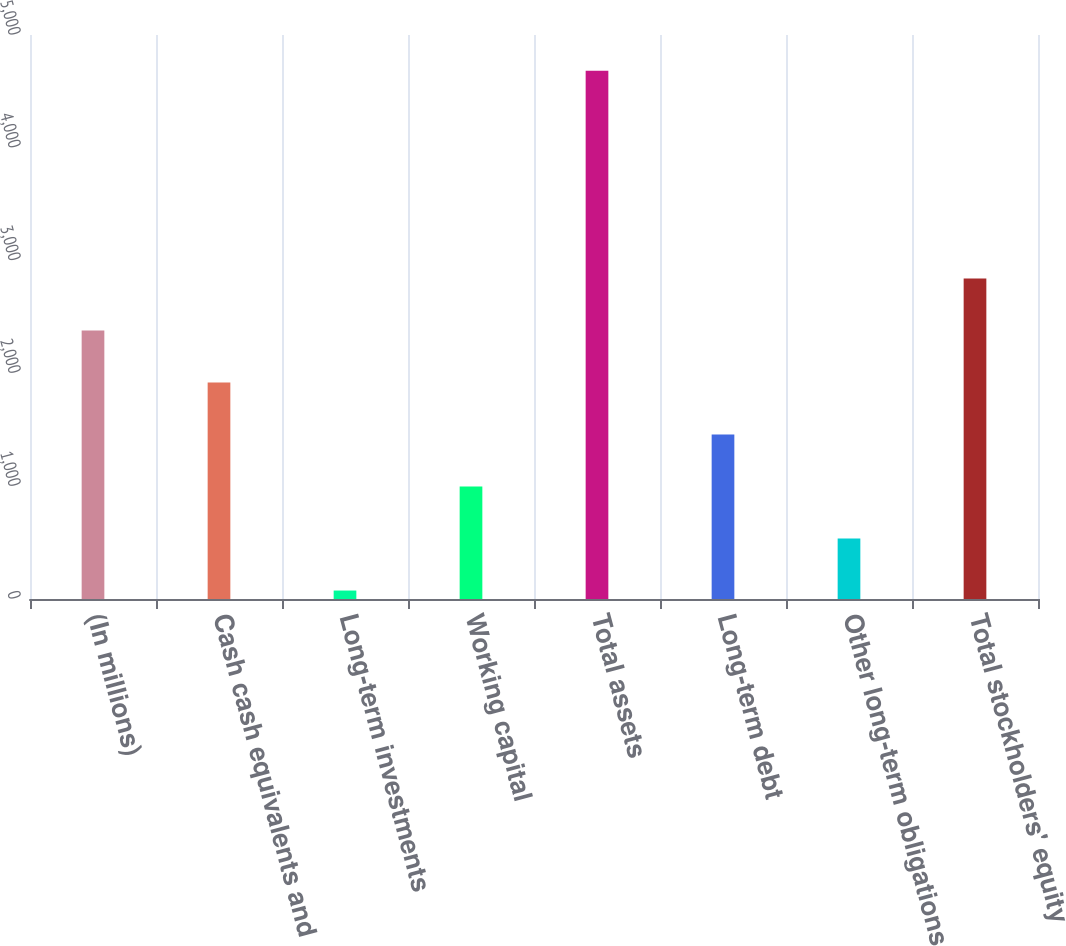<chart> <loc_0><loc_0><loc_500><loc_500><bar_chart><fcel>(In millions)<fcel>Cash cash equivalents and<fcel>Long-term investments<fcel>Working capital<fcel>Total assets<fcel>Long-term debt<fcel>Other long-term obligations<fcel>Total stockholders' equity<nl><fcel>2379.5<fcel>1918.6<fcel>75<fcel>996.8<fcel>4684<fcel>1457.7<fcel>535.9<fcel>2840.4<nl></chart> 